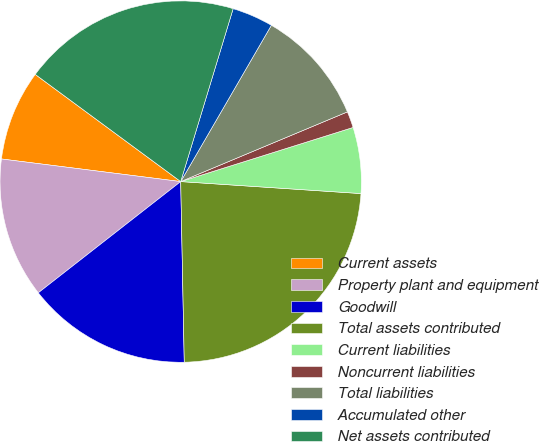<chart> <loc_0><loc_0><loc_500><loc_500><pie_chart><fcel>Current assets<fcel>Property plant and equipment<fcel>Goodwill<fcel>Total assets contributed<fcel>Current liabilities<fcel>Noncurrent liabilities<fcel>Total liabilities<fcel>Accumulated other<fcel>Net assets contributed<nl><fcel>8.11%<fcel>12.55%<fcel>14.76%<fcel>23.63%<fcel>5.9%<fcel>1.46%<fcel>10.33%<fcel>3.68%<fcel>19.58%<nl></chart> 